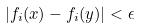<formula> <loc_0><loc_0><loc_500><loc_500>| f _ { i } ( x ) - f _ { i } ( y ) | < \epsilon</formula> 